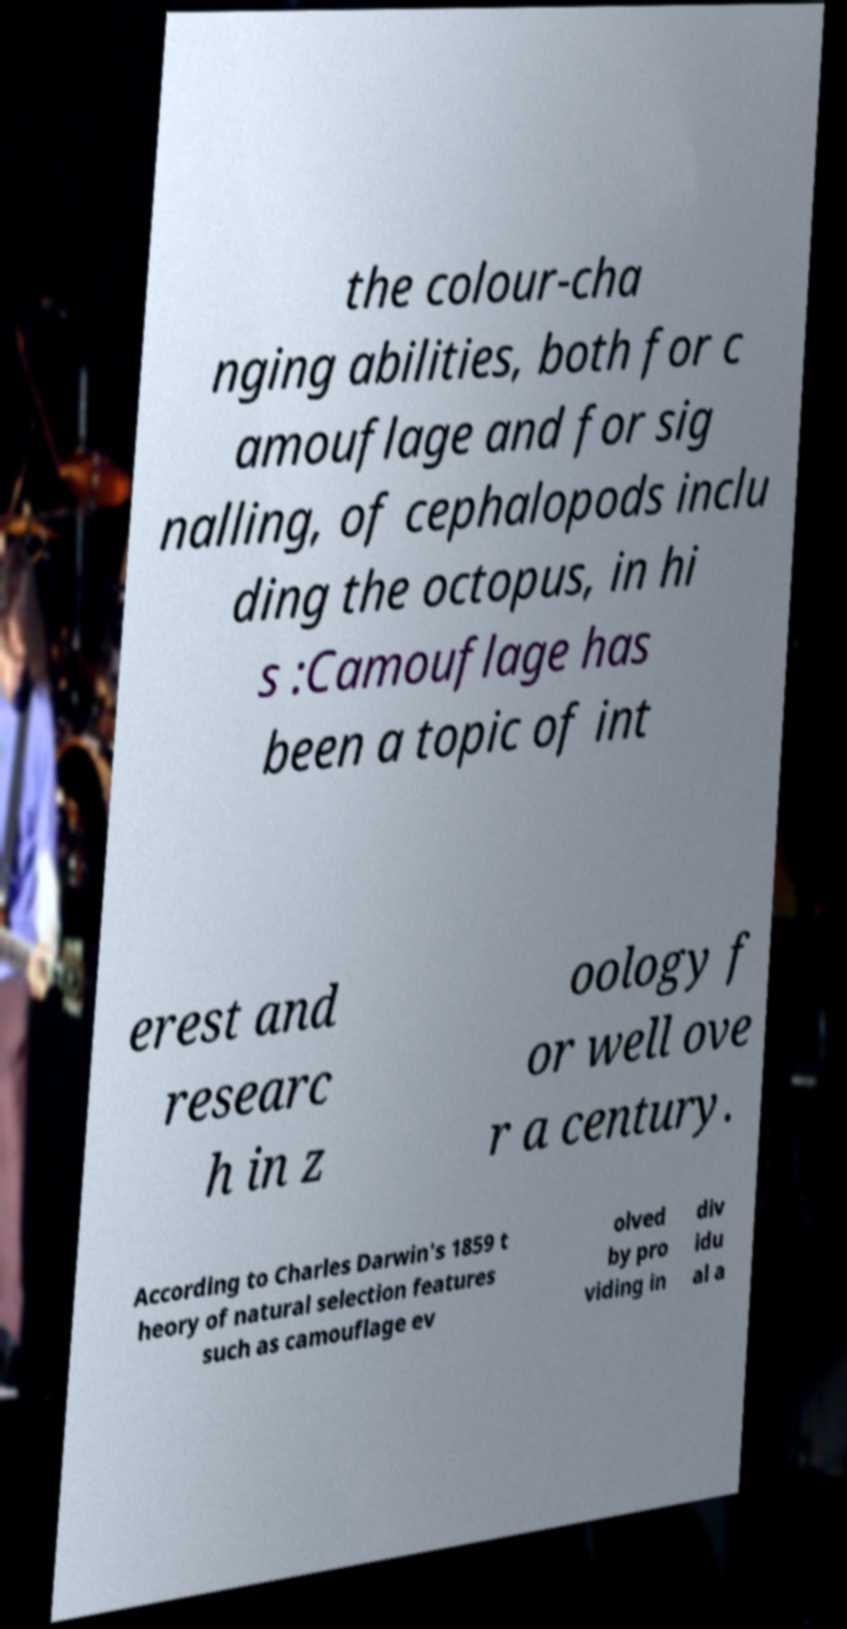I need the written content from this picture converted into text. Can you do that? the colour-cha nging abilities, both for c amouflage and for sig nalling, of cephalopods inclu ding the octopus, in hi s :Camouflage has been a topic of int erest and researc h in z oology f or well ove r a century. According to Charles Darwin's 1859 t heory of natural selection features such as camouflage ev olved by pro viding in div idu al a 